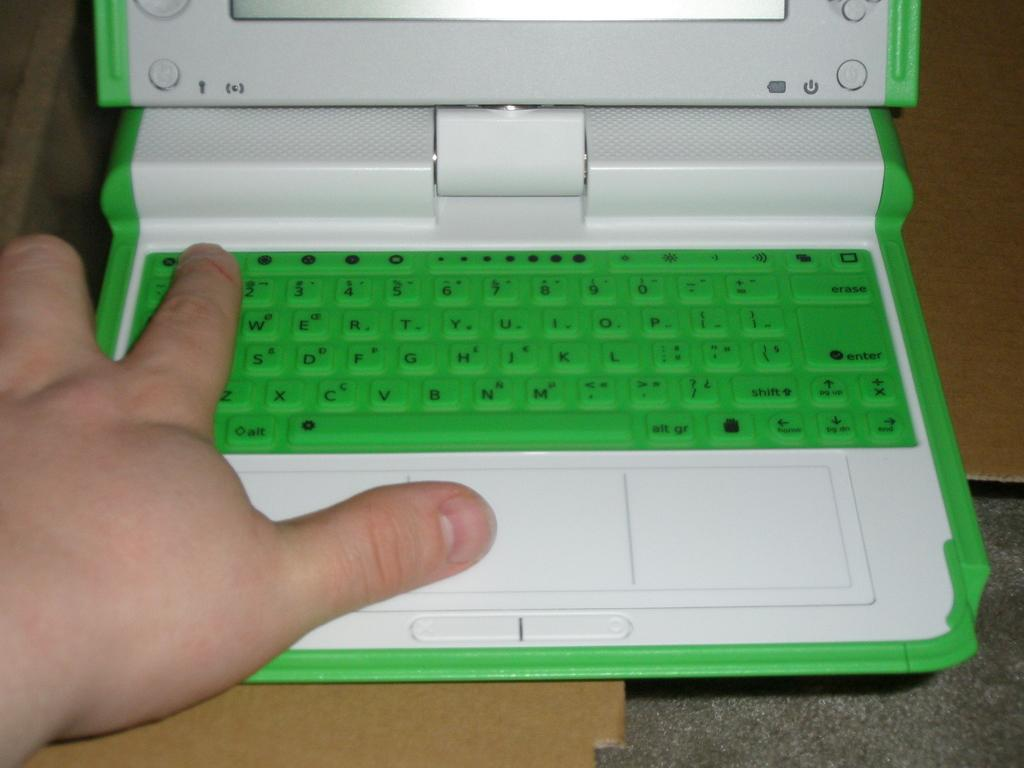<image>
Share a concise interpretation of the image provided. A person holds their finger next to the 3 and W keys on a green keyboard. 